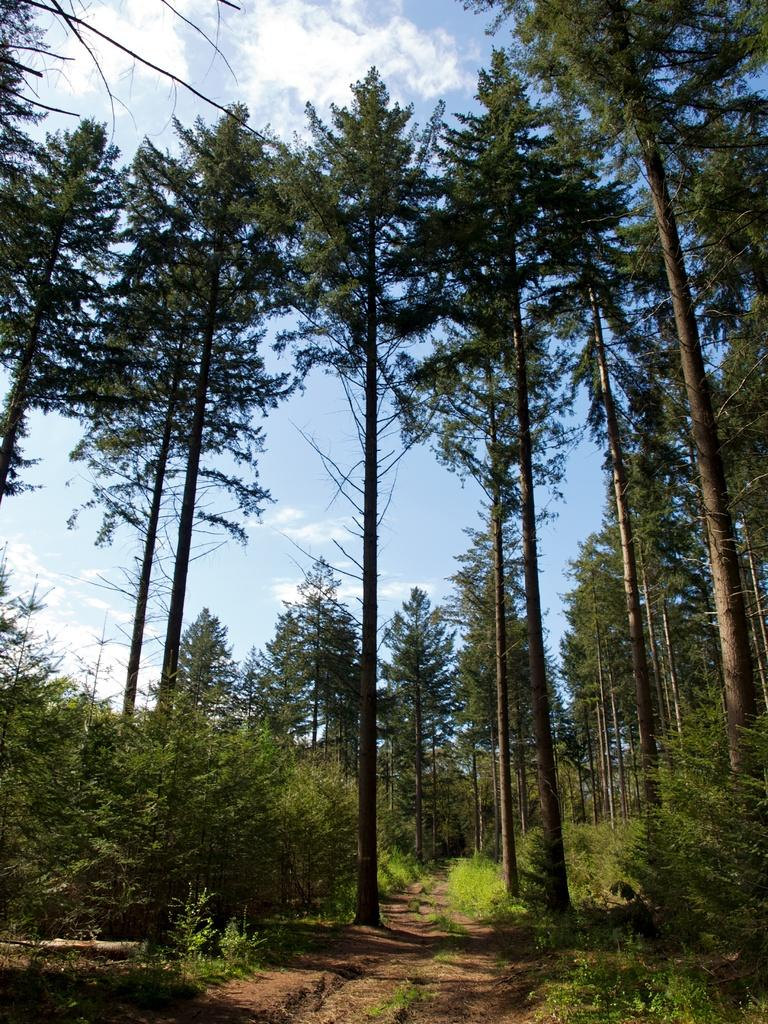What is located in the foreground of the image? There is a path in the foreground of the image. Where is the path situated in relation to the image? The path is in the middle of the image. What type of vegetation is present on either side of the path? There are trees on either side of the path. What can be seen at the top of the image? The sky is visible at the top of the image. Are there any clouds in the sky? Yes, there is at least one cloud in the sky. How many cents are visible on the path in the image? There are no cents visible on the path in the image. What type of border surrounds the trees in the image? There is no border surrounding the trees in the image; they are simply situated on either side of the path. 